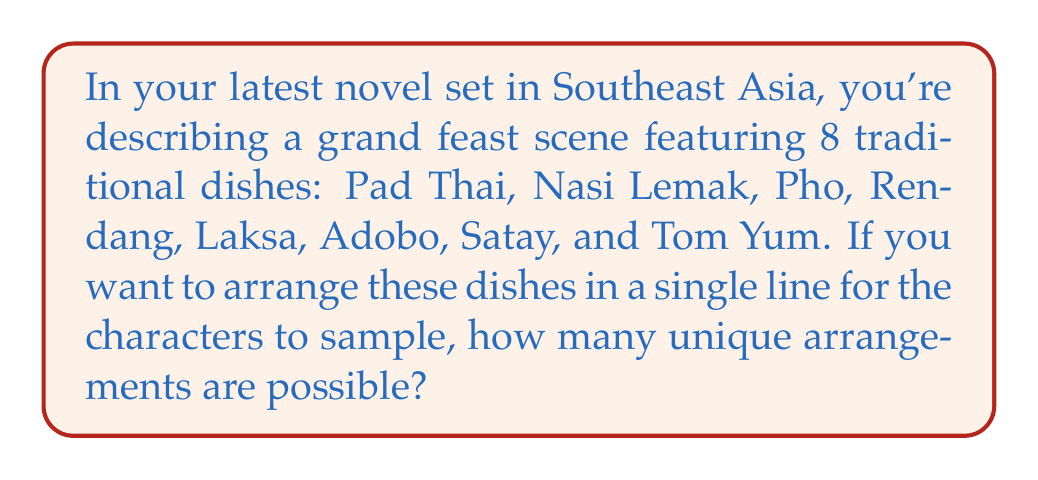What is the answer to this math problem? Let's approach this step-by-step:

1) This is a permutation problem. We are arranging all 8 dishes in a specific order, and each dish can only be used once.

2) In permutation problems where all items are used and order matters, we use the formula:

   $$ P(n) = n! $$

   Where $n$ is the number of items to be arranged.

3) In this case, $n = 8$ (the number of dishes).

4) Therefore, we calculate:

   $$ P(8) = 8! $$

5) Let's expand this:

   $$ 8! = 8 \times 7 \times 6 \times 5 \times 4 \times 3 \times 2 \times 1 $$

6) Calculating this out:

   $$ 8! = 40,320 $$

Thus, there are 40,320 unique ways to arrange these 8 Southeast Asian dishes in a line.
Answer: 40,320 